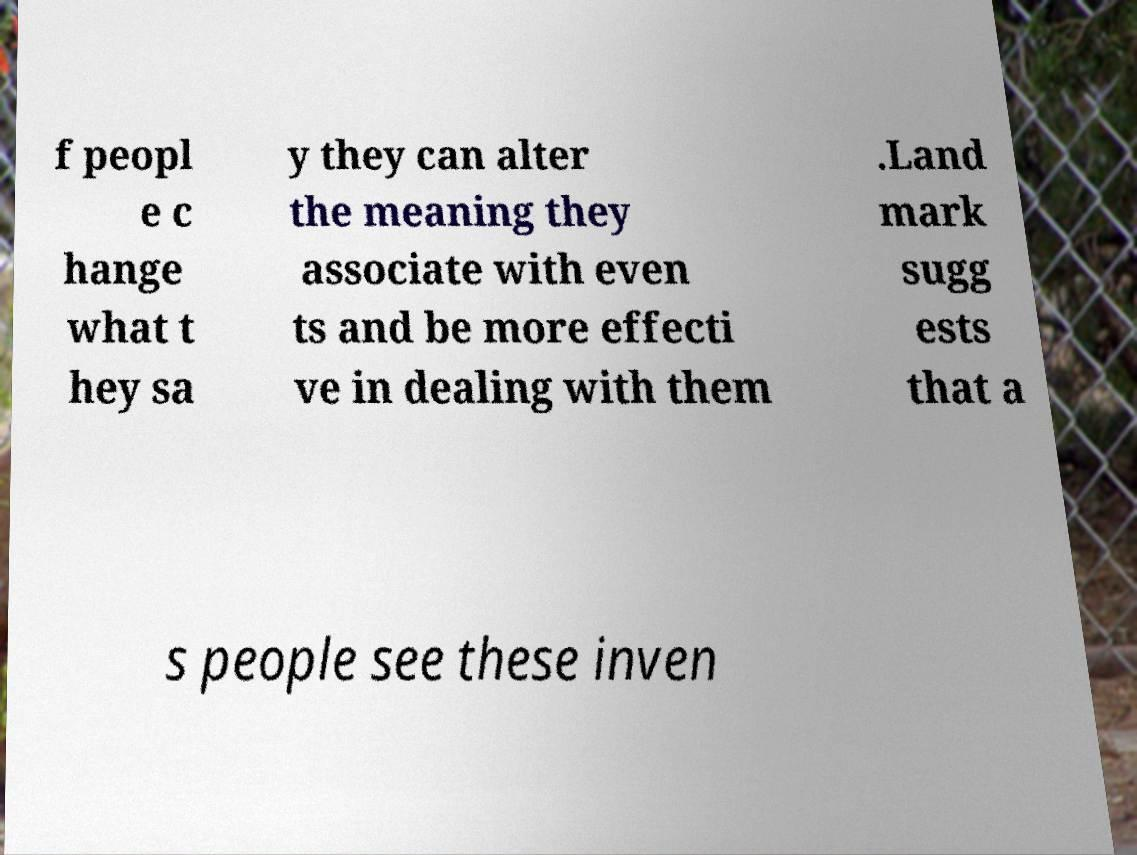Could you extract and type out the text from this image? f peopl e c hange what t hey sa y they can alter the meaning they associate with even ts and be more effecti ve in dealing with them .Land mark sugg ests that a s people see these inven 